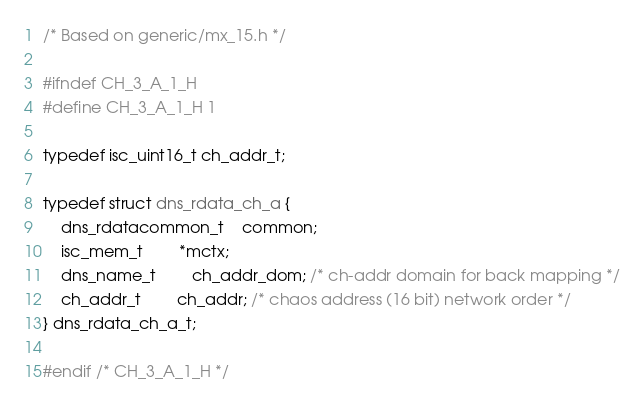Convert code to text. <code><loc_0><loc_0><loc_500><loc_500><_C_>/* Based on generic/mx_15.h */

#ifndef CH_3_A_1_H
#define CH_3_A_1_H 1

typedef isc_uint16_t ch_addr_t;

typedef struct dns_rdata_ch_a {
	dns_rdatacommon_t	common;
	isc_mem_t		*mctx;
  	dns_name_t		ch_addr_dom; /* ch-addr domain for back mapping */
	ch_addr_t		ch_addr; /* chaos address (16 bit) network order */
} dns_rdata_ch_a_t;

#endif /* CH_3_A_1_H */
</code> 